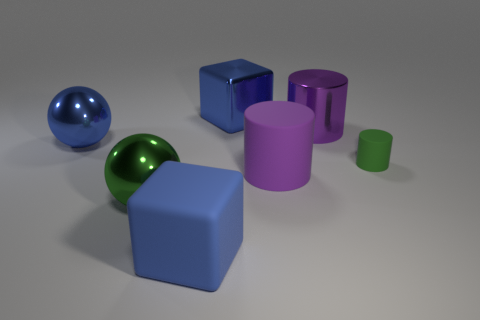Add 2 blue rubber cubes. How many objects exist? 9 Subtract all blocks. How many objects are left? 5 Subtract 0 blue cylinders. How many objects are left? 7 Subtract all large green matte objects. Subtract all purple metallic cylinders. How many objects are left? 6 Add 4 green spheres. How many green spheres are left? 5 Add 7 blue objects. How many blue objects exist? 10 